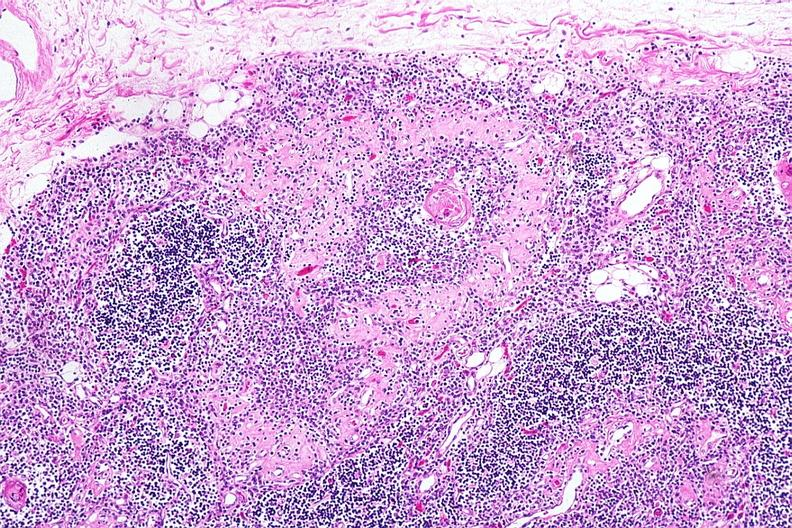what is present?
Answer the question using a single word or phrase. Thymus 